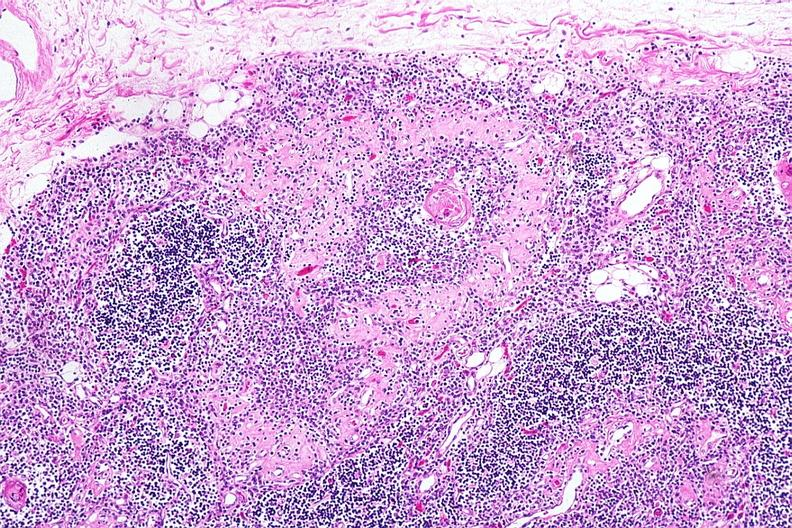what is present?
Answer the question using a single word or phrase. Thymus 